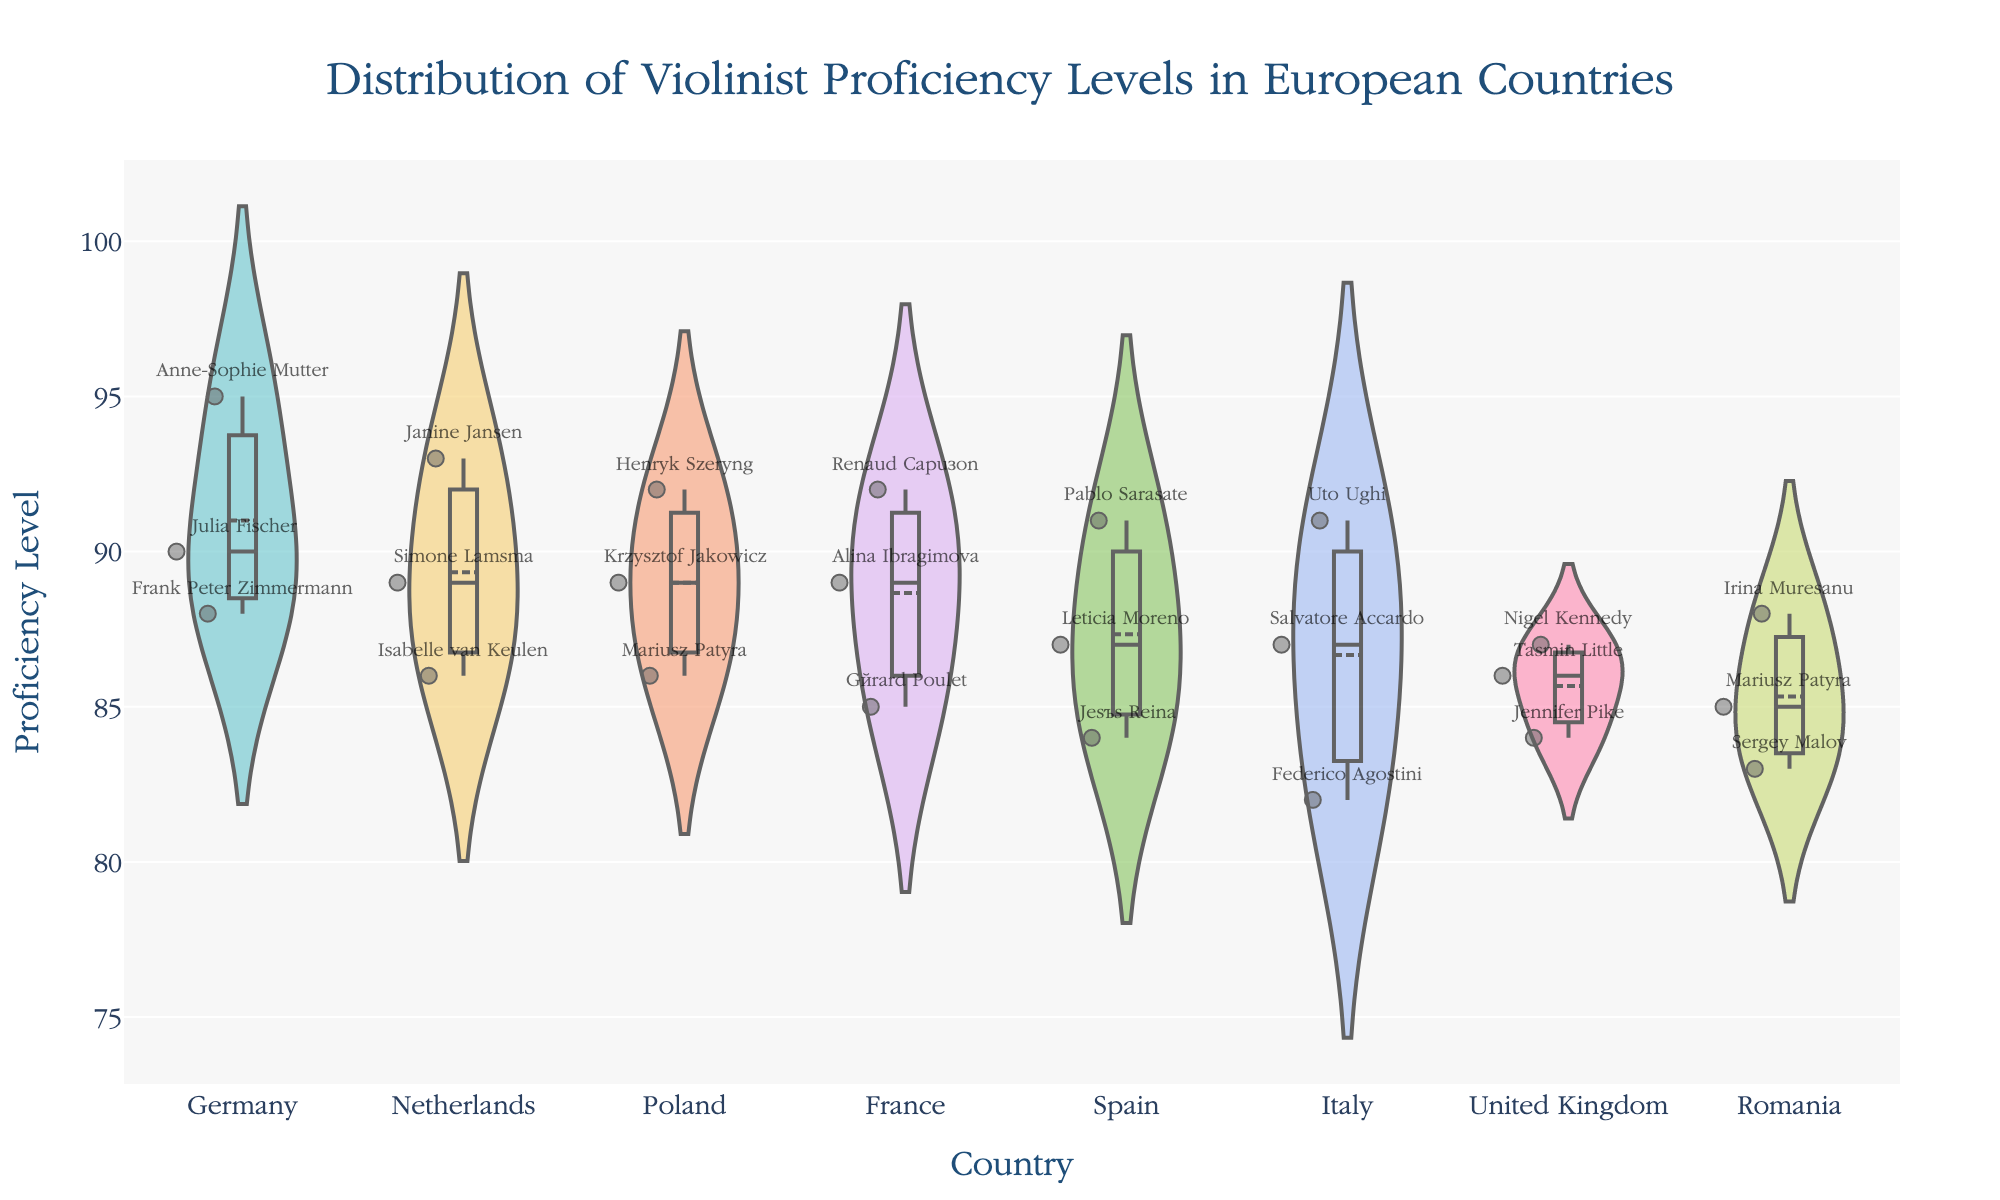What is the title of the plot? The title is prominently displayed at the top of the plot. It is designed to give an overview of what the figure represents.
Answer: "Distribution of Violinist Proficiency Levels in European Countries" Which country has the violinist with the highest proficiency level? By looking at the plot, locate the highest point on the y-axis across all countries. The highest point has a violinist's name annotation which corresponds to that country.
Answer: Germany Which country has the lowest average proficiency level? Observe the arrangement of countries on the x-axis, which is ordered by mean proficiency levels. The country on the farthest right end has the lowest average proficiency.
Answer: Spain How many data points are there for the Netherlands? Look for the jittered points in the area corresponding to the Netherlands on the x-axis. Count the individual points within the Netherlands' violin plot.
Answer: 3 What is the proficiency level of Anne-Sophie Mutter? Using the annotation within the plot, identify Anne-Sophie Mutter. The numerical value next to her name indicates her proficiency level.
Answer: 95 Compare the mean proficiency levels of Germany and France. Look at the meanlines within the violin plots for both Germany and France. Compare the height of these meanlines on the y-axis.
Answer: Germany's mean proficiency is higher than France's Which country shows the most variation in violinist proficiency levels? Examine the spread or width of the violin plots. The country with the widest violin plot area shows the greatest variation in proficiency levels.
Answer: United Kingdom Are there any outliers in Romania's proficiency levels? Inspect the jittered points around Romania's violin plot. An outlier would be a point far removed from the dense central area of the violin plot.
Answer: No, there are no significant outliers What is the mean proficiency level of violinists in Italy? Identify Italy's violin plot and locate the meanline. Read the y-axis value where the meanline intersects.
Answer: 86.67 Which country has more violinists with proficiency levels above 90? Germany or Netherlands? Count the number of jittered points above the 90 mark on the y-axis for both Germany and Netherlands. Compare the counts to determine which country has more violinists above 90.
Answer: Germany 